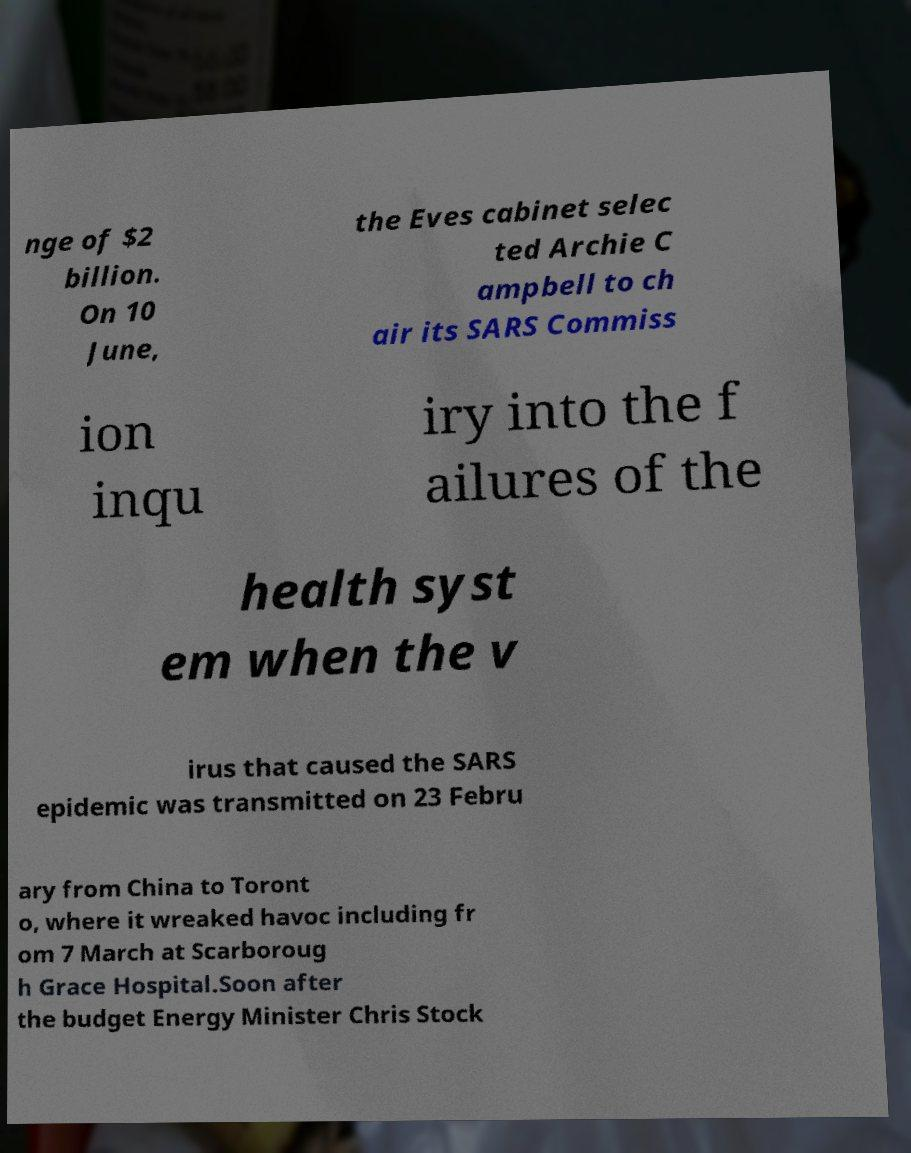For documentation purposes, I need the text within this image transcribed. Could you provide that? nge of $2 billion. On 10 June, the Eves cabinet selec ted Archie C ampbell to ch air its SARS Commiss ion inqu iry into the f ailures of the health syst em when the v irus that caused the SARS epidemic was transmitted on 23 Febru ary from China to Toront o, where it wreaked havoc including fr om 7 March at Scarboroug h Grace Hospital.Soon after the budget Energy Minister Chris Stock 